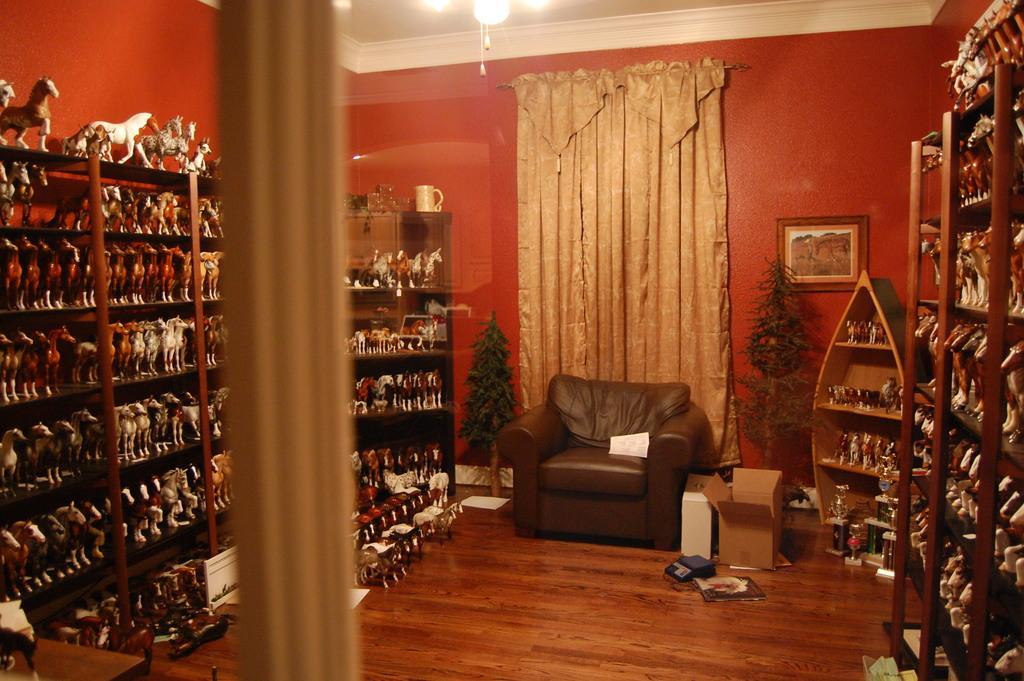Can you describe this image briefly? In the foreground of the picture, there it seems like a pole and in the background, there are many toys in the rack on either side. We can also see a sofa, trees and few more objects on the floor. Behind it, there is a curtain, a frame on the wall and the chandelier at the top. 